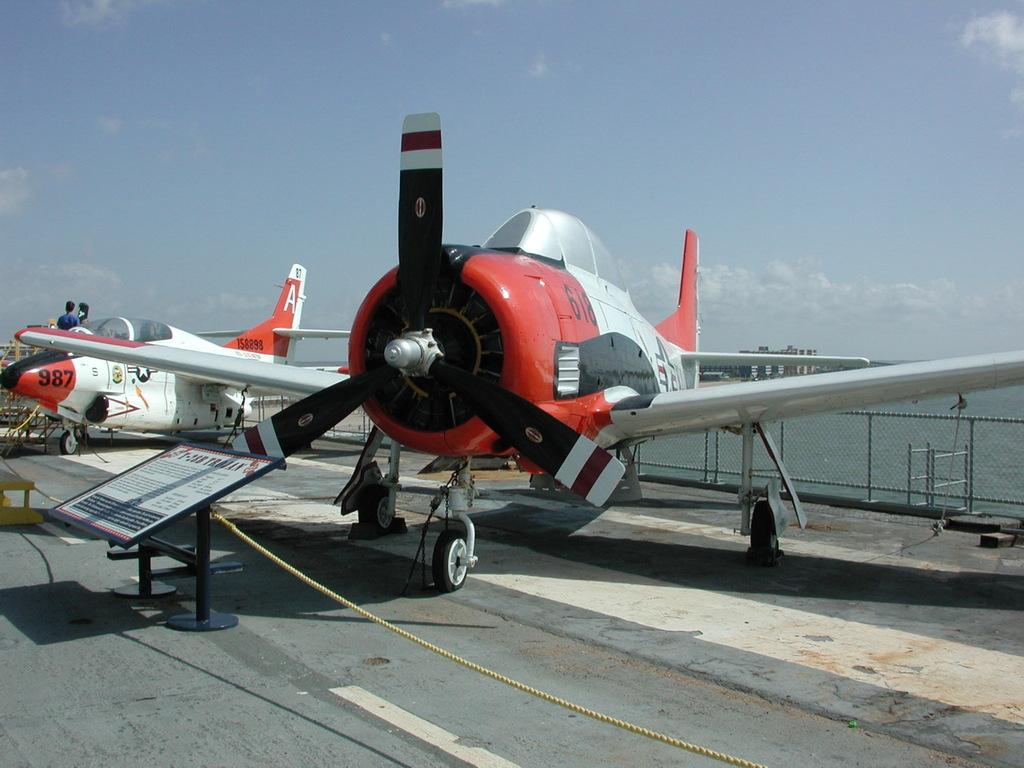<image>
Render a clear and concise summary of the photo. airplanes on display including one with number 987 on the nose cone 